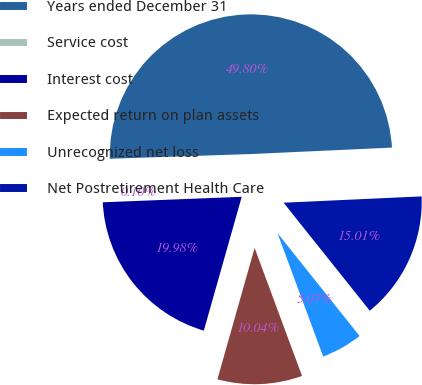Convert chart to OTSL. <chart><loc_0><loc_0><loc_500><loc_500><pie_chart><fcel>Years ended December 31<fcel>Service cost<fcel>Interest cost<fcel>Expected return on plan assets<fcel>Unrecognized net loss<fcel>Net Postretirement Health Care<nl><fcel>49.8%<fcel>0.1%<fcel>19.98%<fcel>10.04%<fcel>5.07%<fcel>15.01%<nl></chart> 